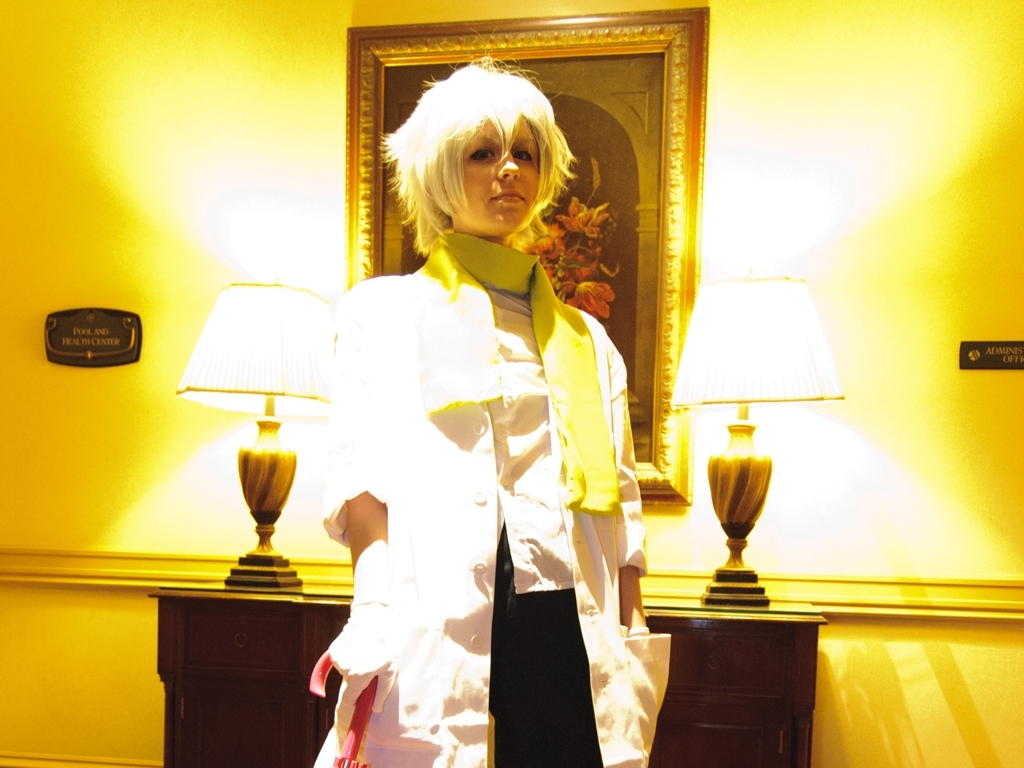What can you infer about the location where this photo was taken? The setting appears to be an indoor environment, likely a hallway or a room corner, suggested by the wall decorations, lamps, and furniture. The plaques on the wall hint at a formal or professional establishment. 